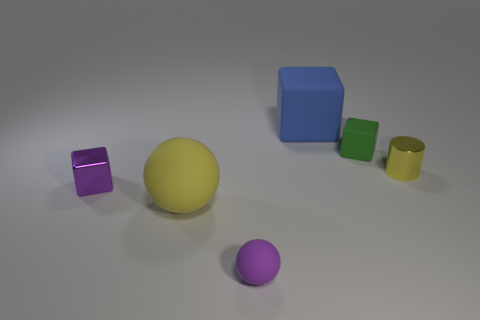Add 3 metal cylinders. How many objects exist? 9 Subtract all balls. How many objects are left? 4 Add 4 tiny blocks. How many tiny blocks exist? 6 Subtract 1 green blocks. How many objects are left? 5 Subtract all large objects. Subtract all tiny balls. How many objects are left? 3 Add 2 blue rubber cubes. How many blue rubber cubes are left? 3 